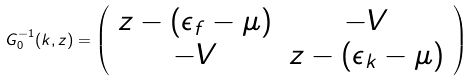Convert formula to latex. <formula><loc_0><loc_0><loc_500><loc_500>G _ { 0 } ^ { - 1 } ( k , z ) = \left ( \begin{array} { c c } z - ( \epsilon _ { f } - \mu ) & - V \\ - V & z - ( \epsilon _ { k } - \mu ) \end{array} \right )</formula> 